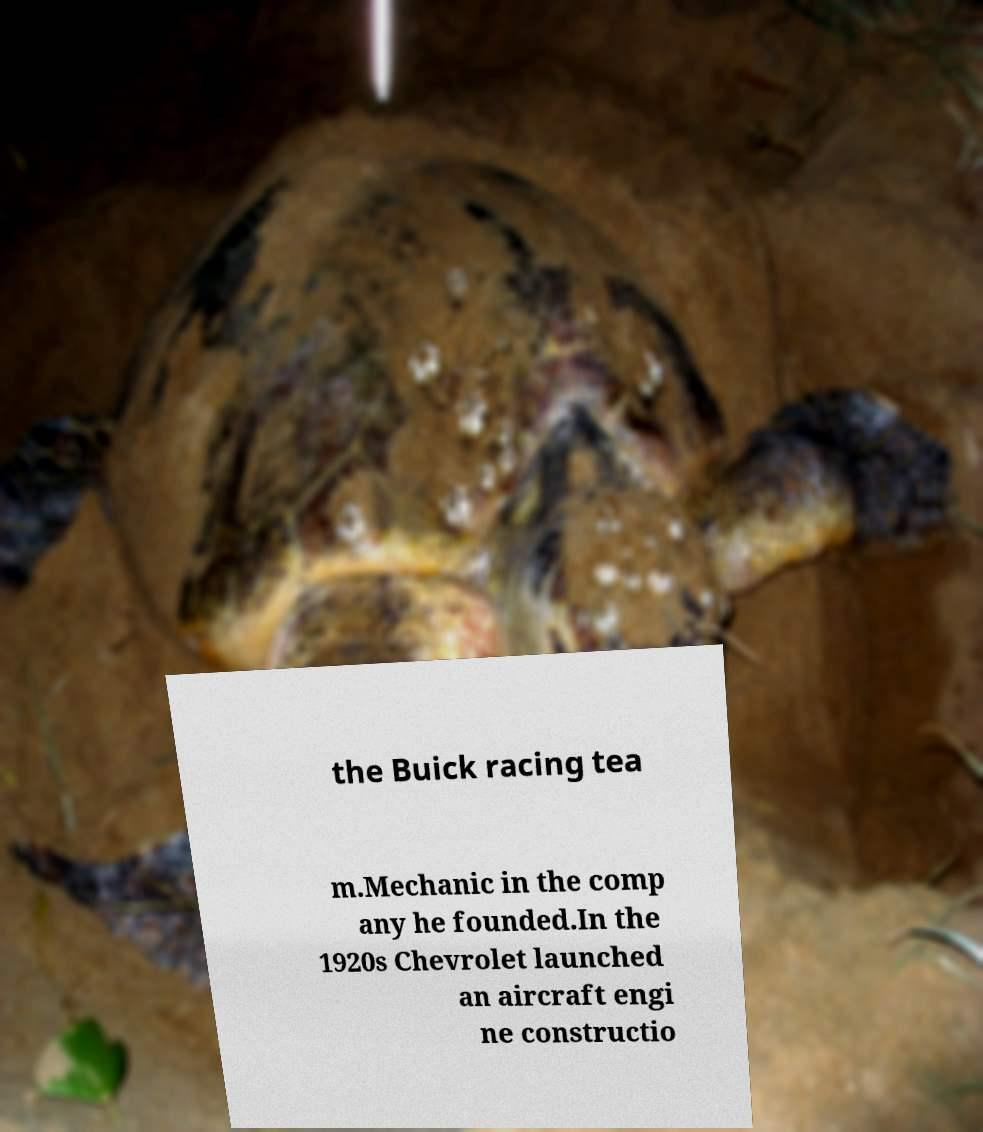Please identify and transcribe the text found in this image. the Buick racing tea m.Mechanic in the comp any he founded.In the 1920s Chevrolet launched an aircraft engi ne constructio 